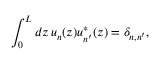Convert formula to latex. <formula><loc_0><loc_0><loc_500><loc_500>\int _ { 0 } ^ { L } d z \, u _ { n } ( z ) u _ { n ^ { \prime } } ^ { * } ( z ) = \delta _ { n , n ^ { \prime } } ,</formula> 